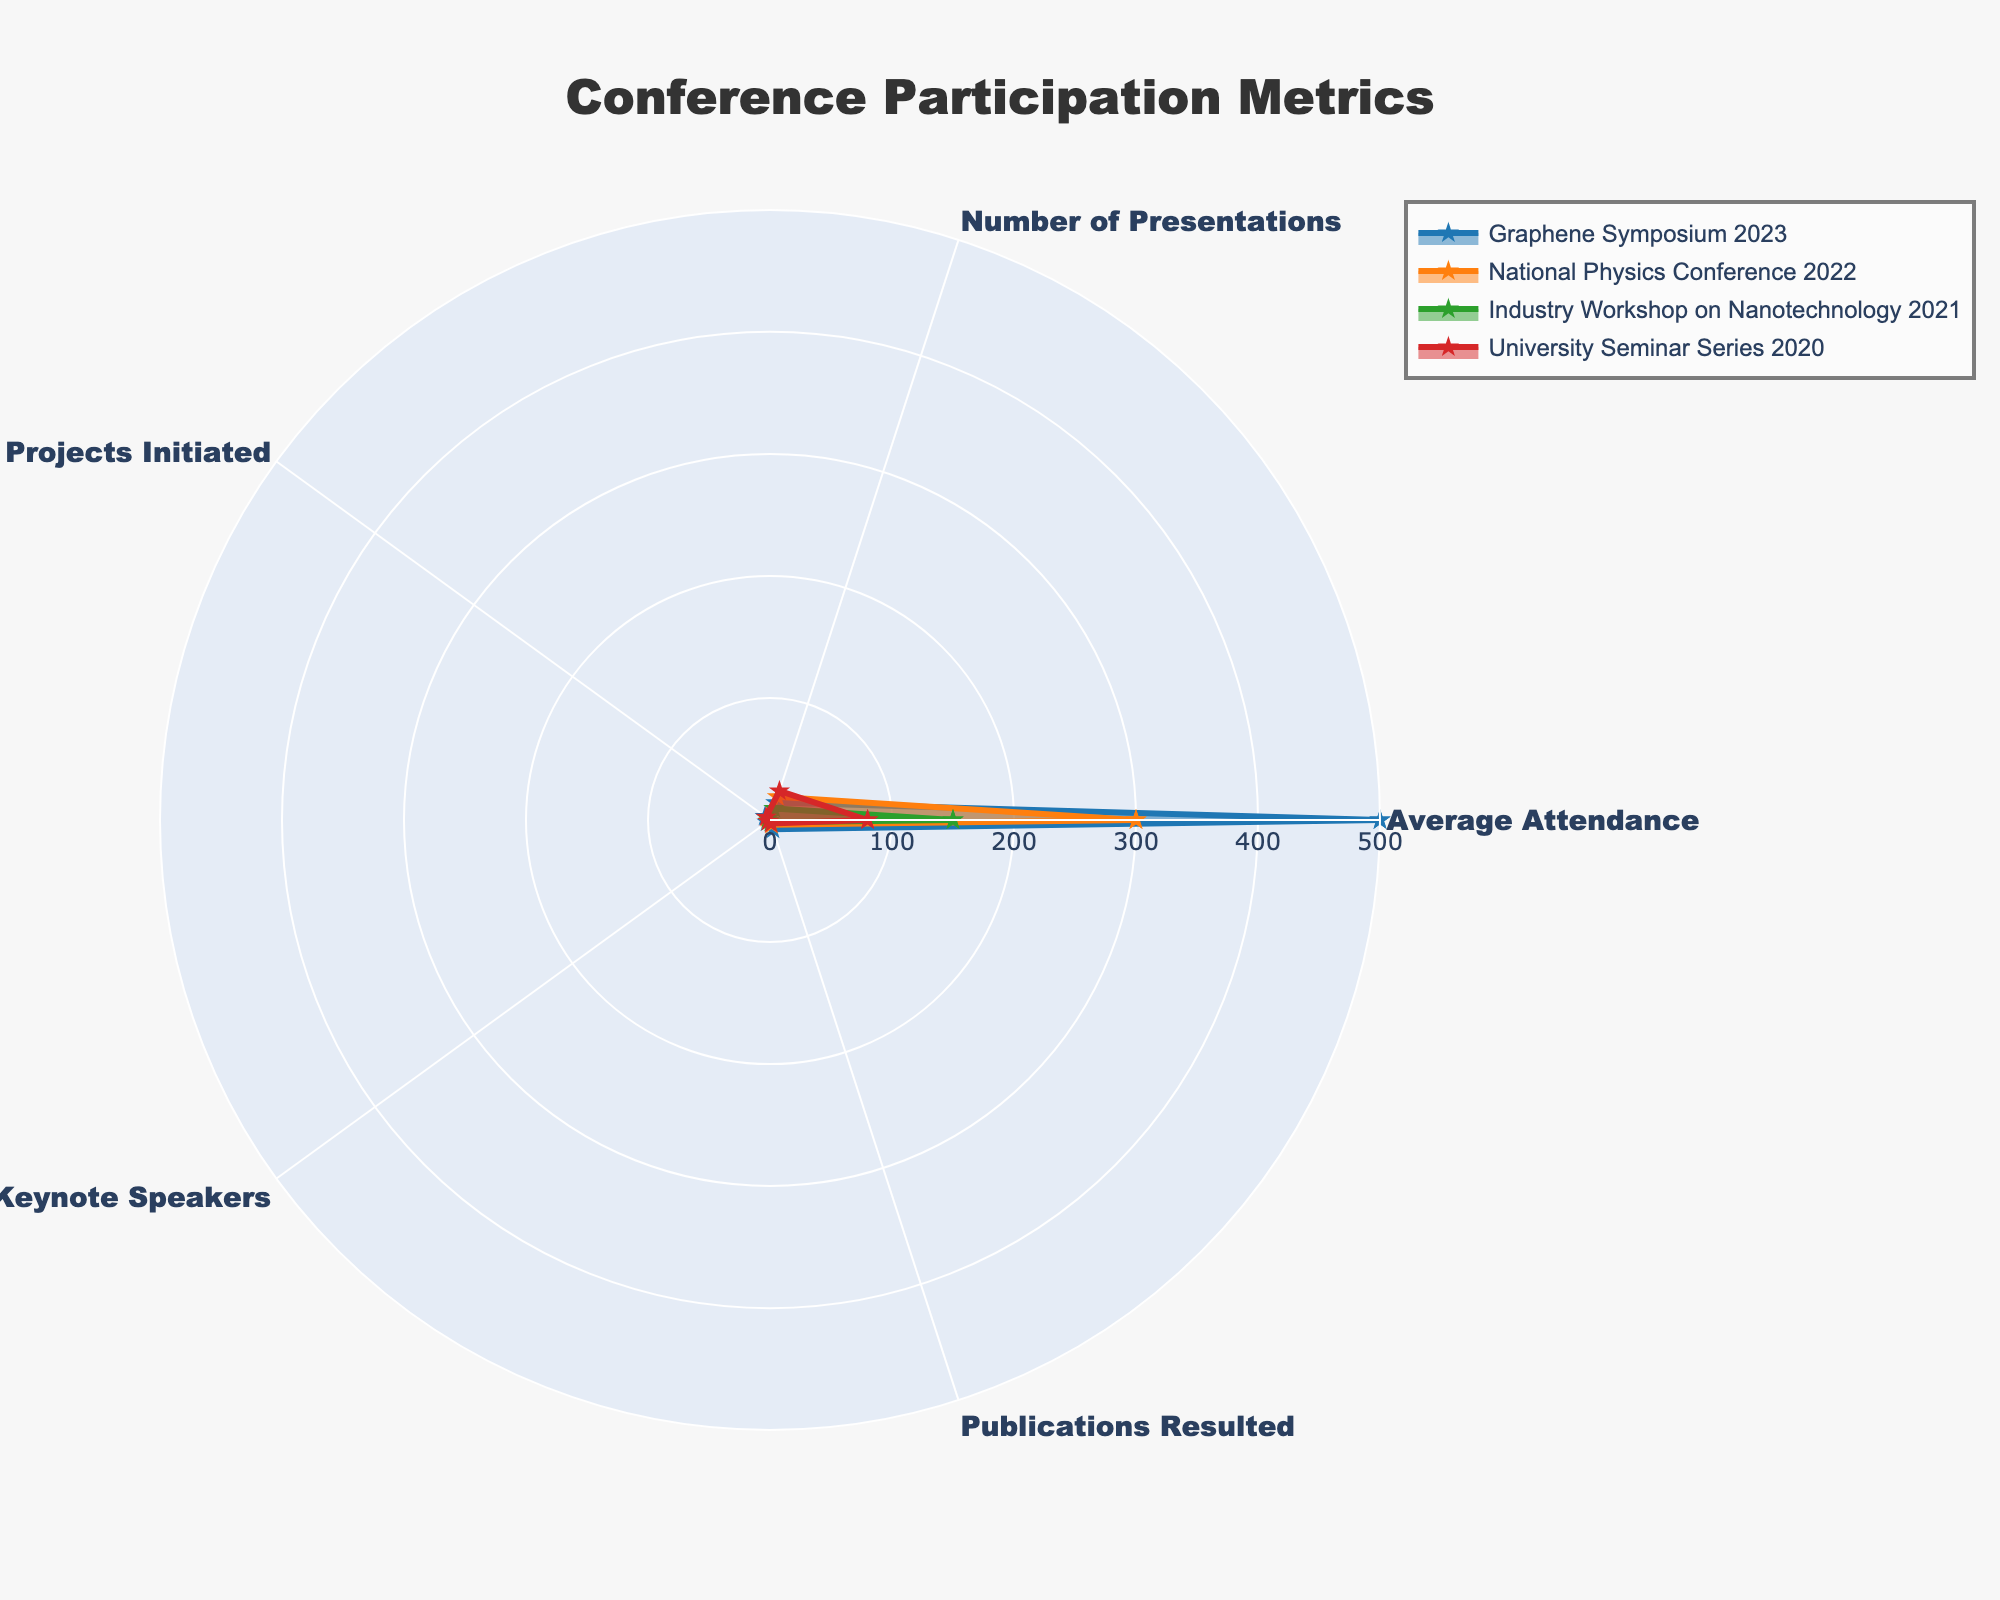How many keynote speakers were at the Industry Workshop on Nanotechnology 2021? Identify the section for "Industry Workshop on Nanotechnology 2021" and look for the "Keynote Speakers" value in the radar chart.
Answer: 1 Which conference had the highest average attendance? Compare the "Average Attendance" values across all conferences: "Graphene Symposium 2023" (500), "National Physics Conference 2022" (300), "Industry Workshop on Nanotechnology 2021" (150), and "University Seminar Series 2020" (80). The "Graphene Symposium 2023" has the highest value.
Answer: Graphene Symposium 2023 How many more publications resulted from the Graphene Symposium 2023 compared to the Industry Workshop on Nanotechnology 2021? Check the number of "Publications Resulted" for both conferences: "Graphene Symposium 2023" (8) and "Industry Workshop on Nanotechnology 2021" (2). Calculate the difference (8 - 2).
Answer: 6 Which two metrics had the same value at the University Seminar Series 2020? Examine the values for "University Seminar Series 2020" across all metrics: "Average Attendance" (80), "Number of Presentations" (25), "Collaborative Projects Initiated" (4), "Keynote Speakers" (2), "Publications Resulted" (3). Identify the pairs with identical values.
Answer: No pairs have the same value What is the total number of collaborative projects initiated by all conferences combined? Sum the "Collaborative Projects Initiated" values for all conferences: Graphene Symposium 2023 (5), National Physics Conference 2022 (3), Industry Workshop on Nanotechnology 2021 (2), University Seminar Series 2020 (4). Total is 5 + 3 + 2 + 4.
Answer: 14 Among the categories “Number of Presentations” and “Collaborative Projects Initiated,” which category shows more variance across the conferences? Compare the ranges: “Number of Presentations” ranges from 10 to 25 (difference of 15) and “Collaborative Projects Initiated” ranges from 2 to 5 (difference of 3). The “Number of Presentations” has the higher range.
Answer: Number of Presentations Did any conference have either 2 or more collaborative projects but fewer than 150 attendees? Check the values: "Industry Workshop on Nanotechnology 2021" had 2 collaborative projects and 150 attendees, "University Seminar Series 2020" had 4 collaborative projects and 80 attendees. "University Seminar Series 2020" meets the criteria.
Answer: University Seminar Series 2020 Which metric has the smallest variation across the different conferences? Compare the ranges of values for all metrics. "Keynote Speakers" ranges from 1 to 3 (difference of 2), "Collaborative Projects Initiated" ranges from 2 to 5 (difference of 3), "Publications Resulted" ranges from 2 to 8 (difference of 6), "Average Attendance" ranges from 80 to 500 (difference of 420), "Number of Presentations" ranges from 10 to 25 (difference of 15). "Keynote Speakers" has the smallest range.
Answer: Keynote Speakers 